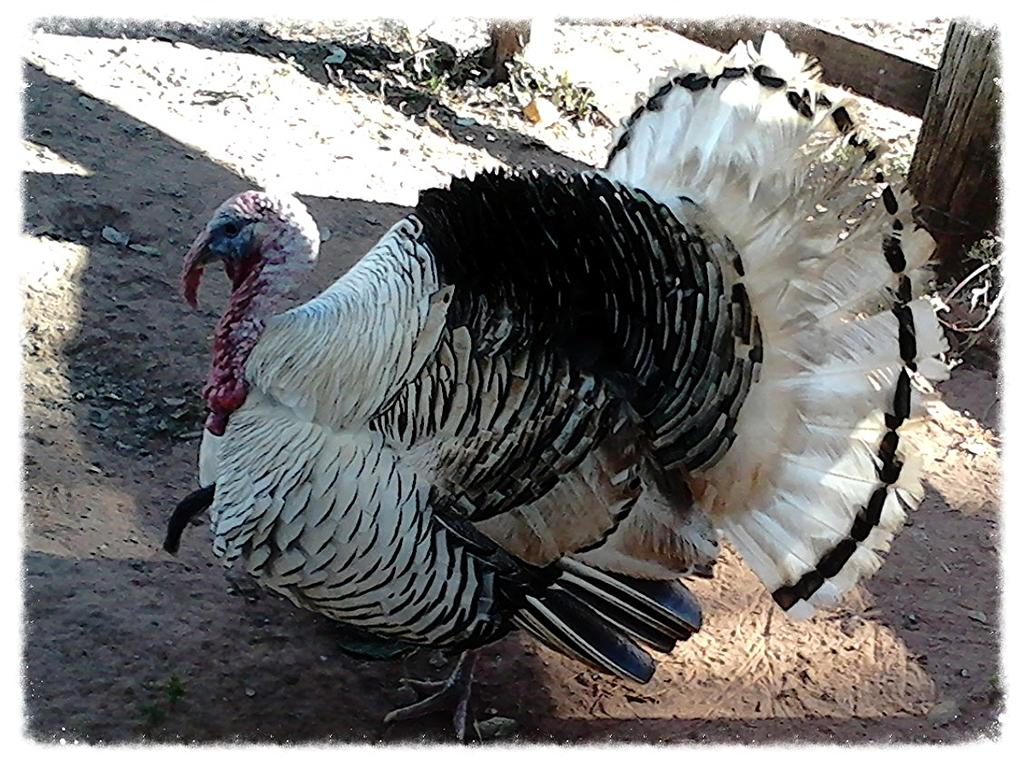What animal is the main subject of the image? There is a turkey in the image. What color is the turkey in the image? The turkey is in black and white color. Where is the turkey located in the image? The turkey is standing on the ground. What can be seen on the ground in the image? There are dry leaves on the ground. What is visible behind the turkey in the image? There is a wooden fencing behind the turkey. What role does the actor play in the peace treaty depicted in the image? There is no actor or peace treaty present in the image; it features a black and white turkey standing on the ground with dry leaves and a wooden fencing in the background. 